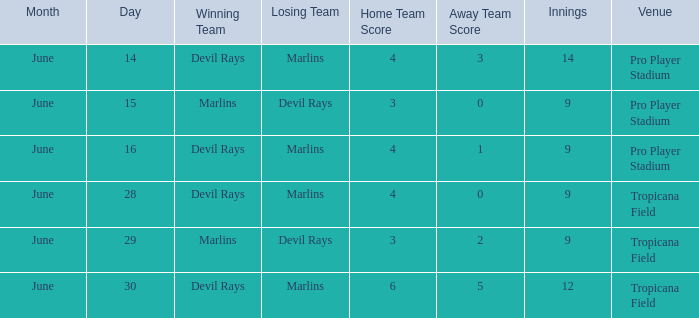On june 14, what was the winning score by the devil rays in pro player stadium? 4-3 (14 innings). 